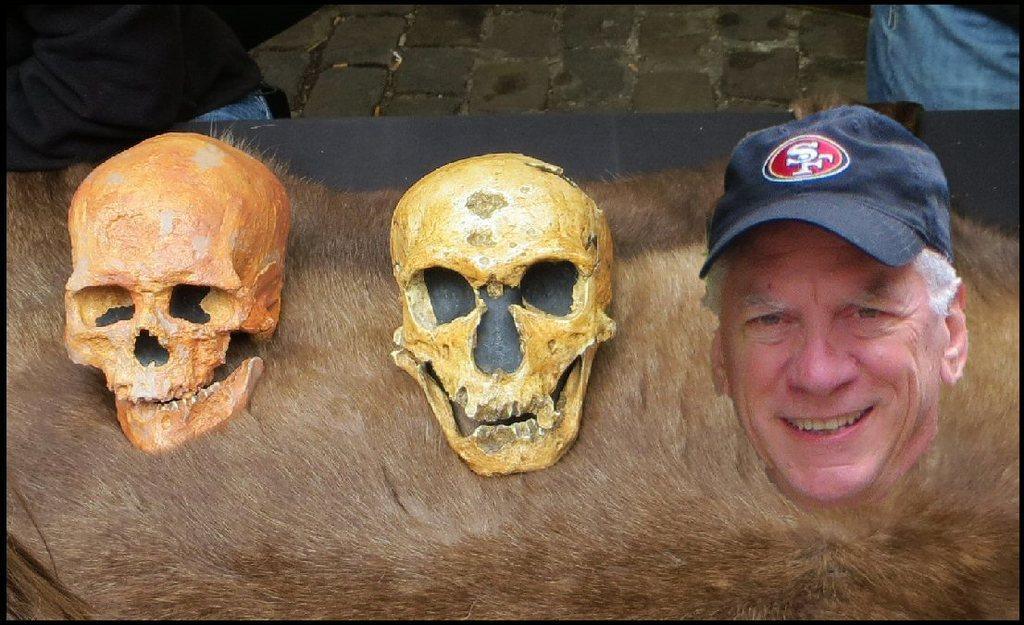How would you summarize this image in a sentence or two? In the image it looks like and edited image, there are two skulls and a person's face on a brown background, behind that there is a path and there are two people on the either side of the path. 